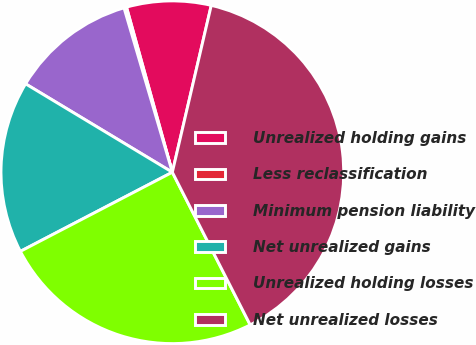Convert chart to OTSL. <chart><loc_0><loc_0><loc_500><loc_500><pie_chart><fcel>Unrealized holding gains<fcel>Less reclassification<fcel>Minimum pension liability<fcel>Net unrealized gains<fcel>Unrealized holding losses<fcel>Net unrealized losses<nl><fcel>7.96%<fcel>0.24%<fcel>11.82%<fcel>16.27%<fcel>24.87%<fcel>38.85%<nl></chart> 